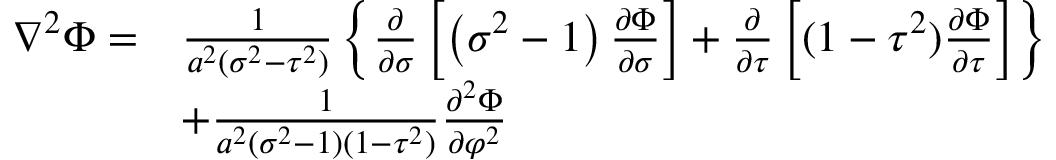Convert formula to latex. <formula><loc_0><loc_0><loc_500><loc_500>{ \begin{array} { r l } { \nabla ^ { 2 } \Phi = } & { { \frac { 1 } { a ^ { 2 } ( \sigma ^ { 2 } - \tau ^ { 2 } ) } } \left \{ { \frac { \partial } { \partial \sigma } } \left [ \left ( \sigma ^ { 2 } - 1 \right ) { \frac { \partial \Phi } { \partial \sigma } } \right ] + { \frac { \partial } { \partial \tau } } \left [ ( 1 - \tau ^ { 2 } ) { \frac { \partial \Phi } { \partial \tau } } \right ] \right \} } \\ & { + { \frac { 1 } { a ^ { 2 } ( \sigma ^ { 2 } - 1 ) ( 1 - \tau ^ { 2 } ) } } { \frac { \partial ^ { 2 } \Phi } { \partial \varphi ^ { 2 } } } } \end{array} }</formula> 